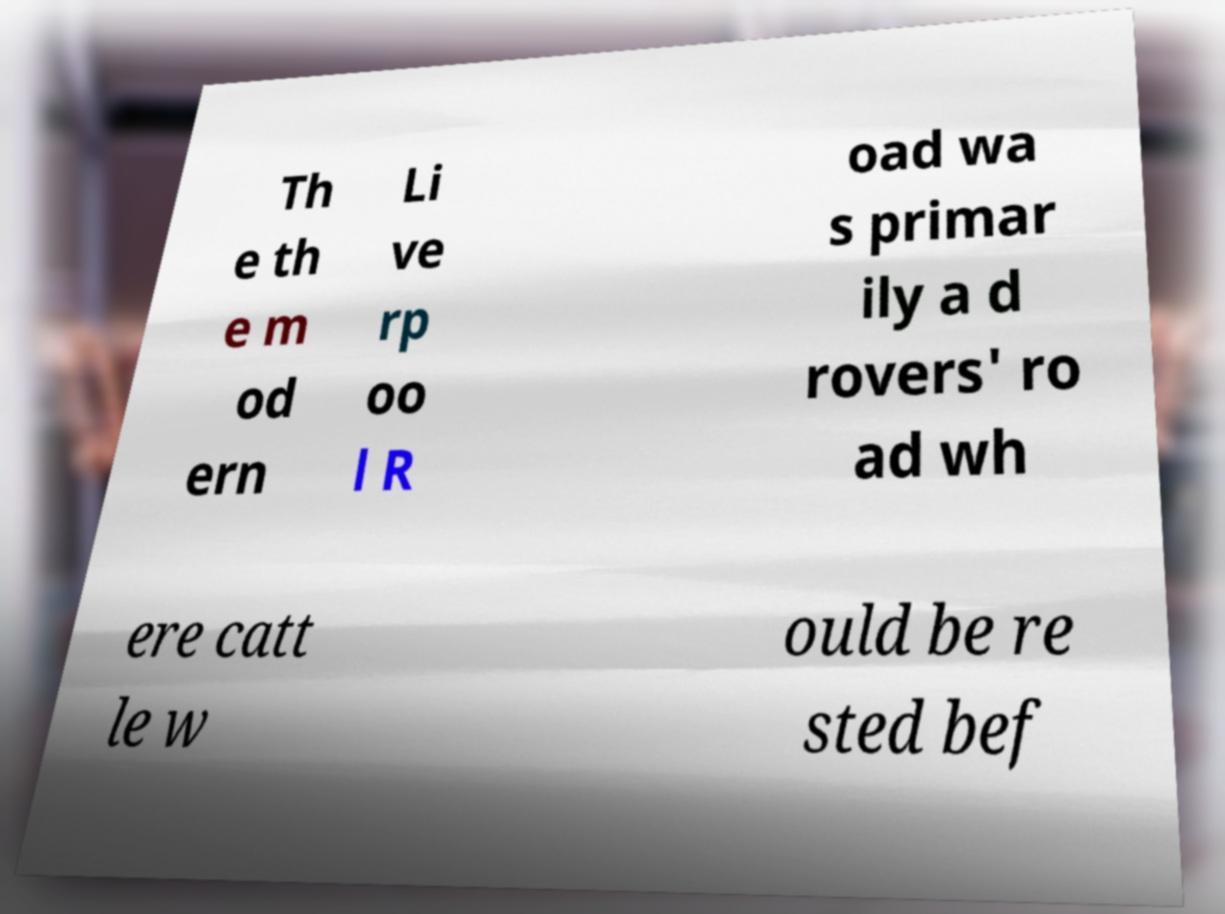Could you extract and type out the text from this image? Th e th e m od ern Li ve rp oo l R oad wa s primar ily a d rovers' ro ad wh ere catt le w ould be re sted bef 